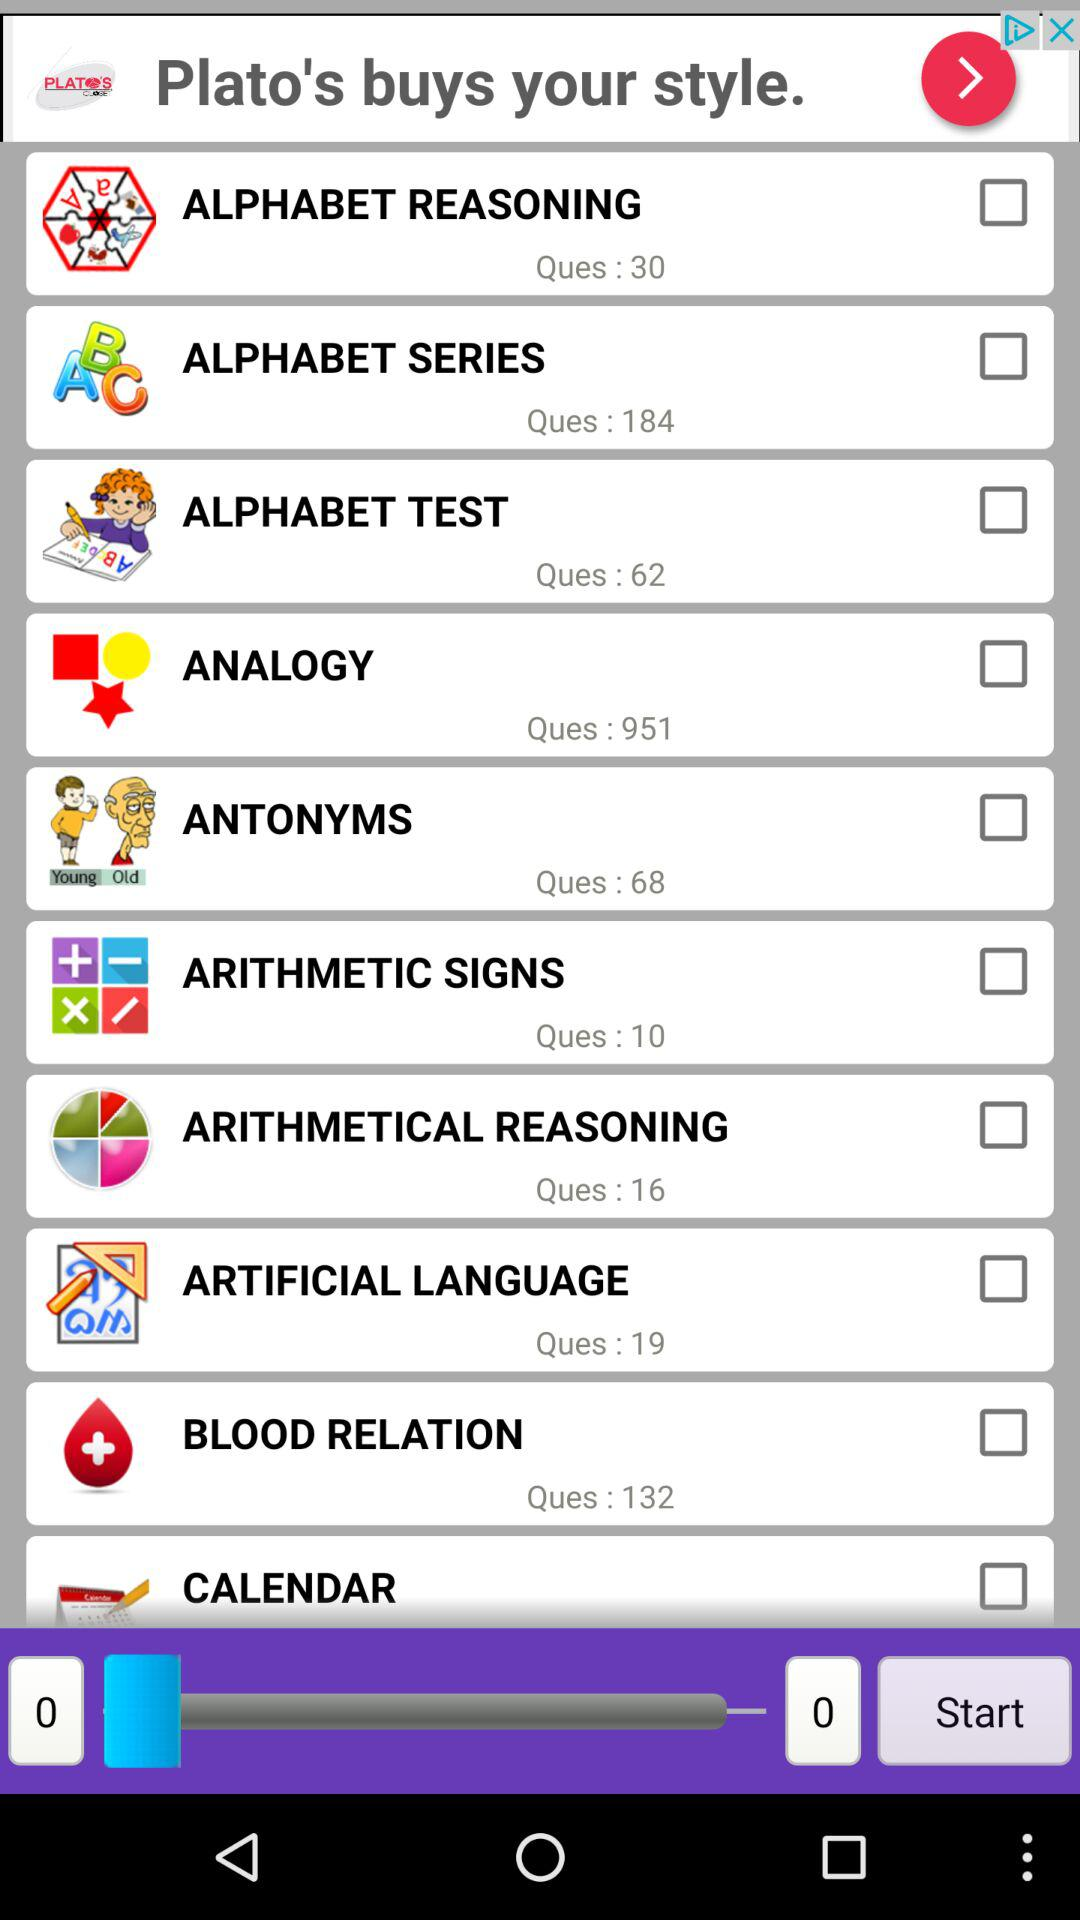How many questions are there in "ALPHABET SERIES"? There are 184 questions in "ALPHABET SERIES". 